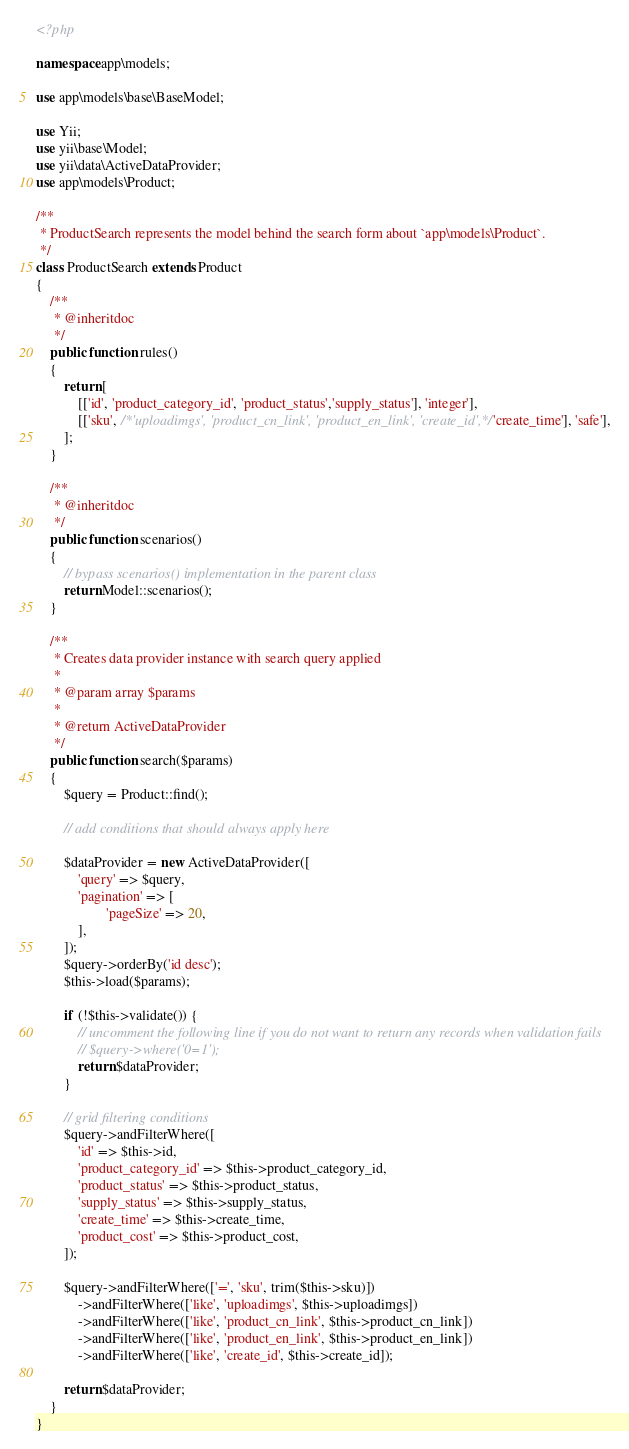Convert code to text. <code><loc_0><loc_0><loc_500><loc_500><_PHP_><?php

namespace app\models;

use app\models\base\BaseModel;

use Yii;
use yii\base\Model;
use yii\data\ActiveDataProvider;
use app\models\Product;

/**
 * ProductSearch represents the model behind the search form about `app\models\Product`.
 */
class ProductSearch extends Product
{
    /**
     * @inheritdoc
     */
    public function rules()
    {
        return [
            [['id', 'product_category_id', 'product_status','supply_status'], 'integer'],
            [['sku', /*'uploadimgs', 'product_cn_link', 'product_en_link', 'create_id',*/ 'create_time'], 'safe'],
        ];
    }

    /**
     * @inheritdoc
     */
    public function scenarios()
    {
        // bypass scenarios() implementation in the parent class
        return Model::scenarios();
    }

    /**
     * Creates data provider instance with search query applied
     *
     * @param array $params
     *
     * @return ActiveDataProvider
     */
    public function search($params)
    {
        $query = Product::find();

        // add conditions that should always apply here

        $dataProvider = new ActiveDataProvider([
            'query' => $query,
            'pagination' => [
                    'pageSize' => 20,
            ],
        ]);
        $query->orderBy('id desc');
        $this->load($params);

        if (!$this->validate()) {
            // uncomment the following line if you do not want to return any records when validation fails
            // $query->where('0=1');
            return $dataProvider;
        }

        // grid filtering conditions
        $query->andFilterWhere([
            'id' => $this->id,
            'product_category_id' => $this->product_category_id,
            'product_status' => $this->product_status,
            'supply_status' => $this->supply_status,
            'create_time' => $this->create_time,
            'product_cost' => $this->product_cost,
        ]);

        $query->andFilterWhere(['=', 'sku', trim($this->sku)])
            ->andFilterWhere(['like', 'uploadimgs', $this->uploadimgs])
            ->andFilterWhere(['like', 'product_cn_link', $this->product_cn_link])
            ->andFilterWhere(['like', 'product_en_link', $this->product_en_link])
            ->andFilterWhere(['like', 'create_id', $this->create_id]);

        return $dataProvider;
    }
}
</code> 